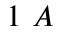Convert formula to latex. <formula><loc_0><loc_0><loc_500><loc_500>1 \ A</formula> 